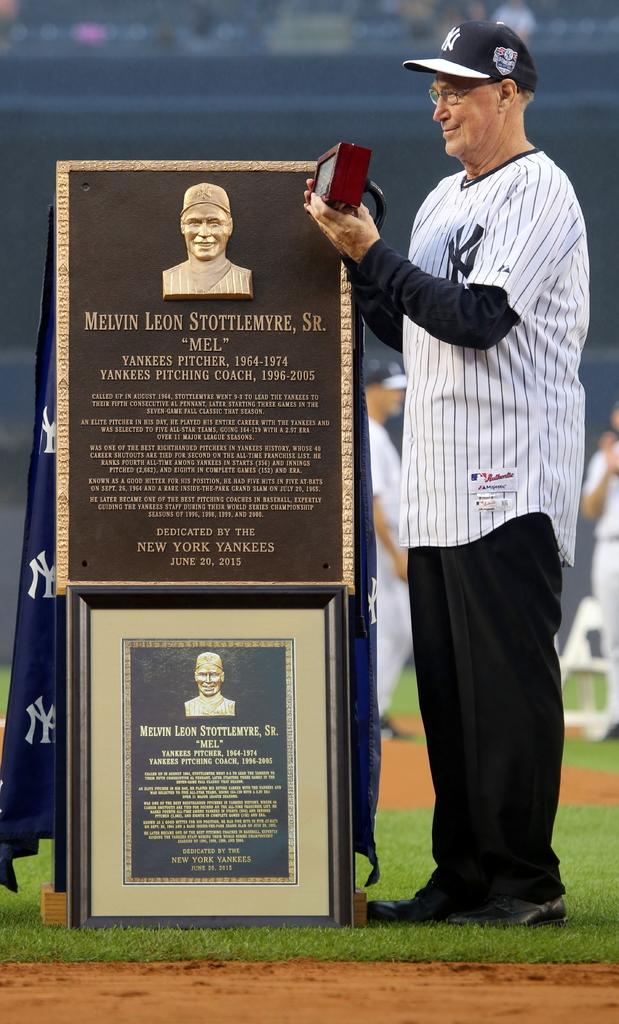<image>
Give a short and clear explanation of the subsequent image. A retired baseball player from the Yankees from 1954-1974 is receiving  an award. 